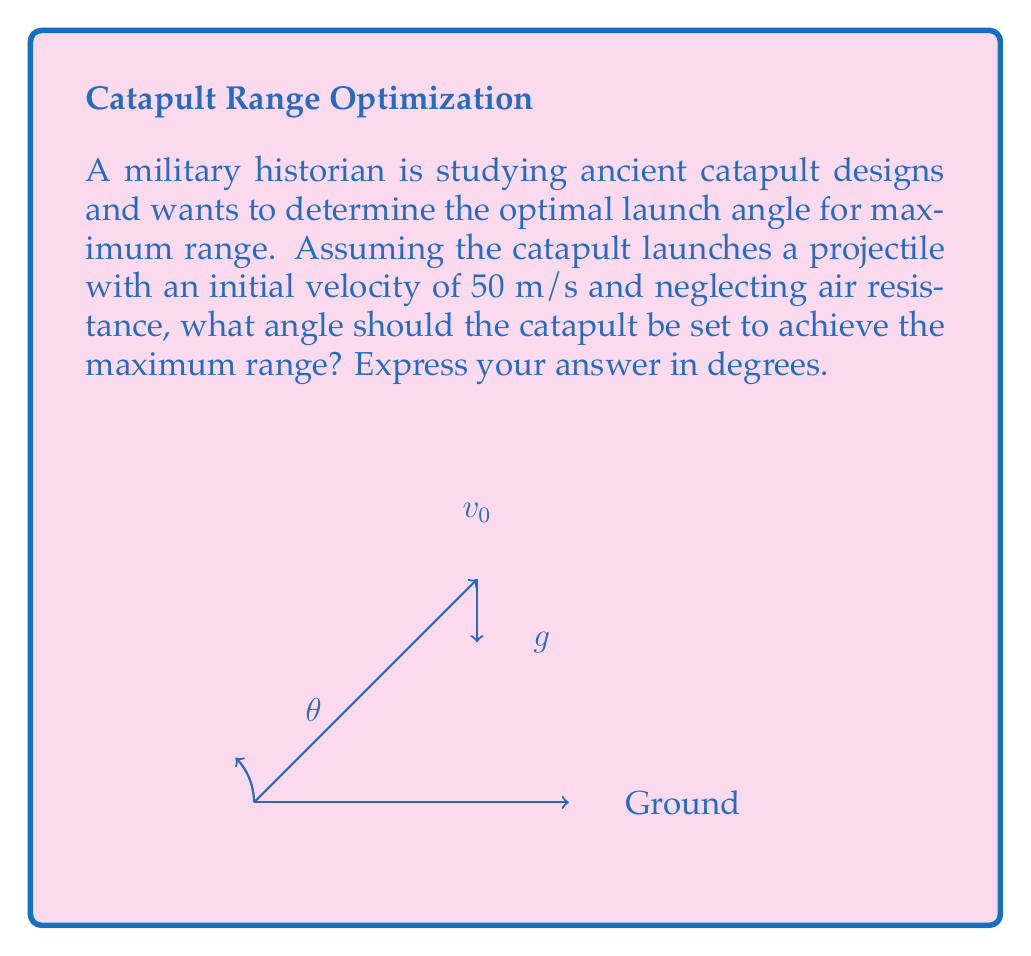Solve this math problem. To solve this problem, we'll use the principles of projectile motion and optimization. The range of a projectile launched from ground level is given by the formula:

$$ R = \frac{v_0^2 \sin(2\theta)}{g} $$

Where:
$R$ is the range
$v_0$ is the initial velocity
$\theta$ is the launch angle
$g$ is the acceleration due to gravity (approximately 9.8 m/s²)

To find the maximum range, we need to maximize the $\sin(2\theta)$ term, as all other terms are constant.

The sine function reaches its maximum value of 1 when its argument is 90°. Therefore:

$$ 2\theta = 90° $$
$$ \theta = 45° $$

This result is independent of the initial velocity and the acceleration due to gravity, making it a universal principle for projectile motion in a uniform gravitational field without air resistance.

To verify, we can check the range at 45° compared to other angles:

At 45°: $R = \frac{50^2 \sin(2 \cdot 45°)}{9.8} = \frac{2500 \cdot 1}{9.8} \approx 255.1$ m

At 30°: $R = \frac{50^2 \sin(2 \cdot 30°)}{9.8} = \frac{2500 \cdot 0.866}{9.8} \approx 220.9$ m

At 60°: $R = \frac{50^2 \sin(2 \cdot 60°)}{9.8} = \frac{2500 \cdot 0.866}{9.8} \approx 220.9$ m

This confirms that 45° indeed gives the maximum range.
Answer: 45° 